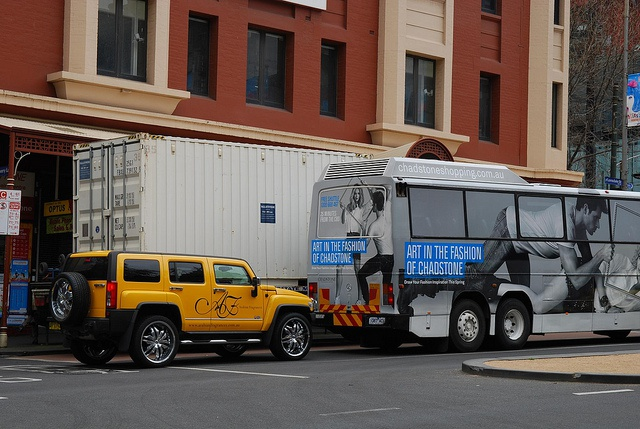Describe the objects in this image and their specific colors. I can see bus in maroon, gray, black, and darkgray tones, truck in maroon, darkgray, gray, and black tones, truck in maroon, black, olive, gray, and orange tones, and car in maroon, black, olive, gray, and orange tones in this image. 